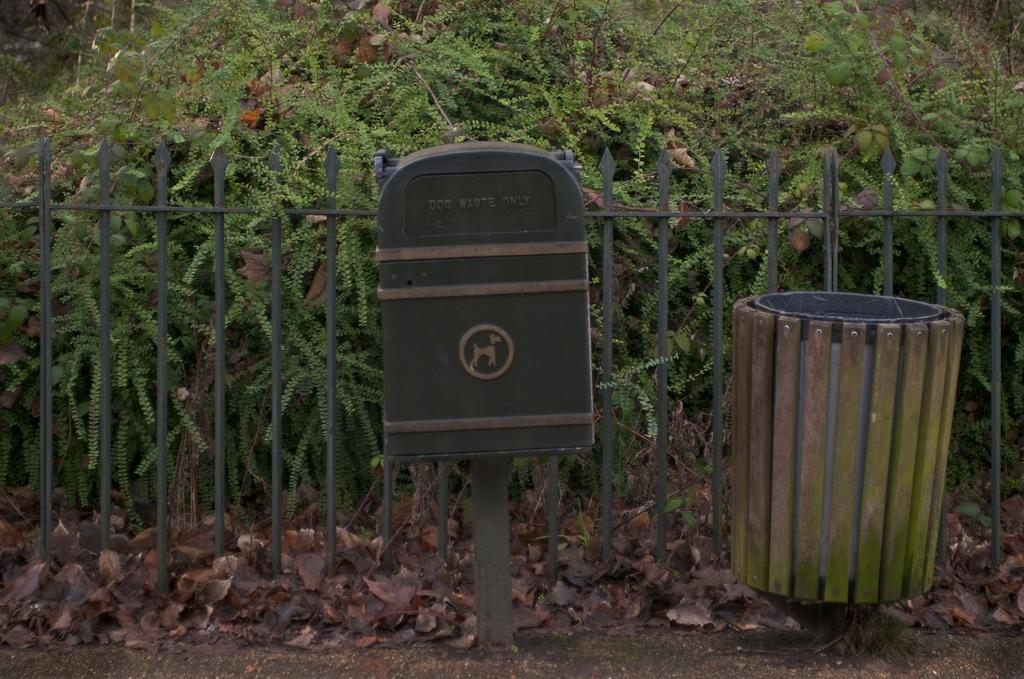<image>
Summarize the visual content of the image. A box in front of a fence clarifies that it is for dog waste only. 